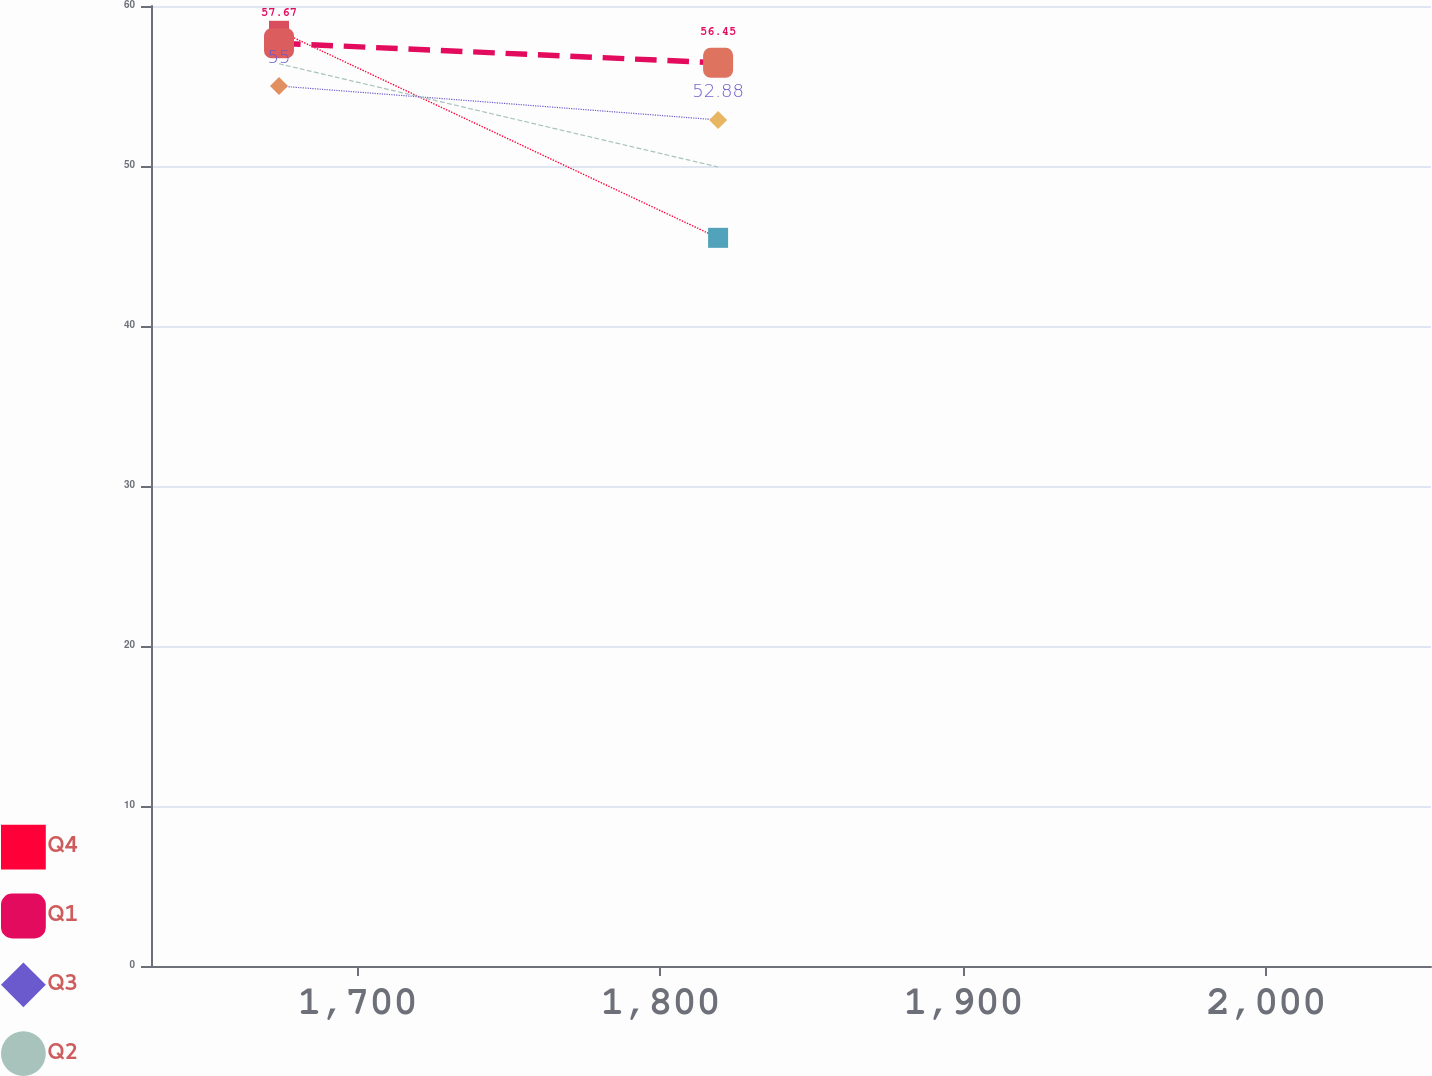Convert chart to OTSL. <chart><loc_0><loc_0><loc_500><loc_500><line_chart><ecel><fcel>Q4<fcel>Q1<fcel>Q3<fcel>Q2<nl><fcel>1674.06<fcel>58.45<fcel>57.67<fcel>55<fcel>56.39<nl><fcel>1819.02<fcel>45.51<fcel>56.45<fcel>52.88<fcel>49.94<nl><fcel>2096.63<fcel>47.6<fcel>57.8<fcel>50.53<fcel>45.78<nl></chart> 